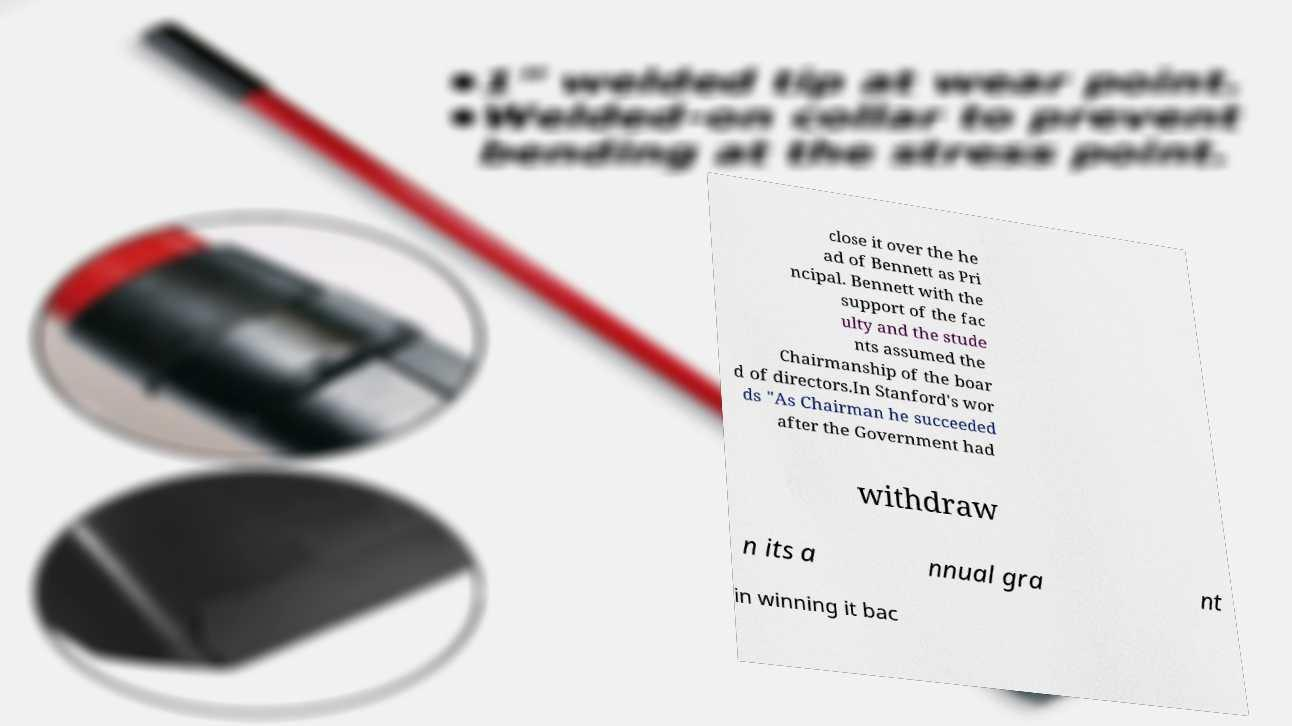Please read and relay the text visible in this image. What does it say? close it over the he ad of Bennett as Pri ncipal. Bennett with the support of the fac ulty and the stude nts assumed the Chairmanship of the boar d of directors.In Stanford's wor ds "As Chairman he succeeded after the Government had withdraw n its a nnual gra nt in winning it bac 